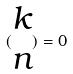Convert formula to latex. <formula><loc_0><loc_0><loc_500><loc_500>( \begin{matrix} k \\ n \end{matrix} ) = 0</formula> 